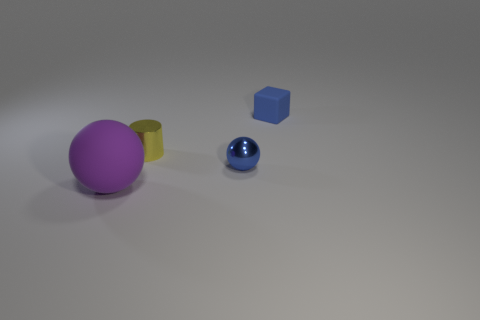Add 1 large purple matte objects. How many objects exist? 5 Subtract all blocks. How many objects are left? 3 Subtract 0 brown blocks. How many objects are left? 4 Subtract all rubber things. Subtract all big brown matte cylinders. How many objects are left? 2 Add 4 tiny yellow cylinders. How many tiny yellow cylinders are left? 5 Add 3 big red metal cylinders. How many big red metal cylinders exist? 3 